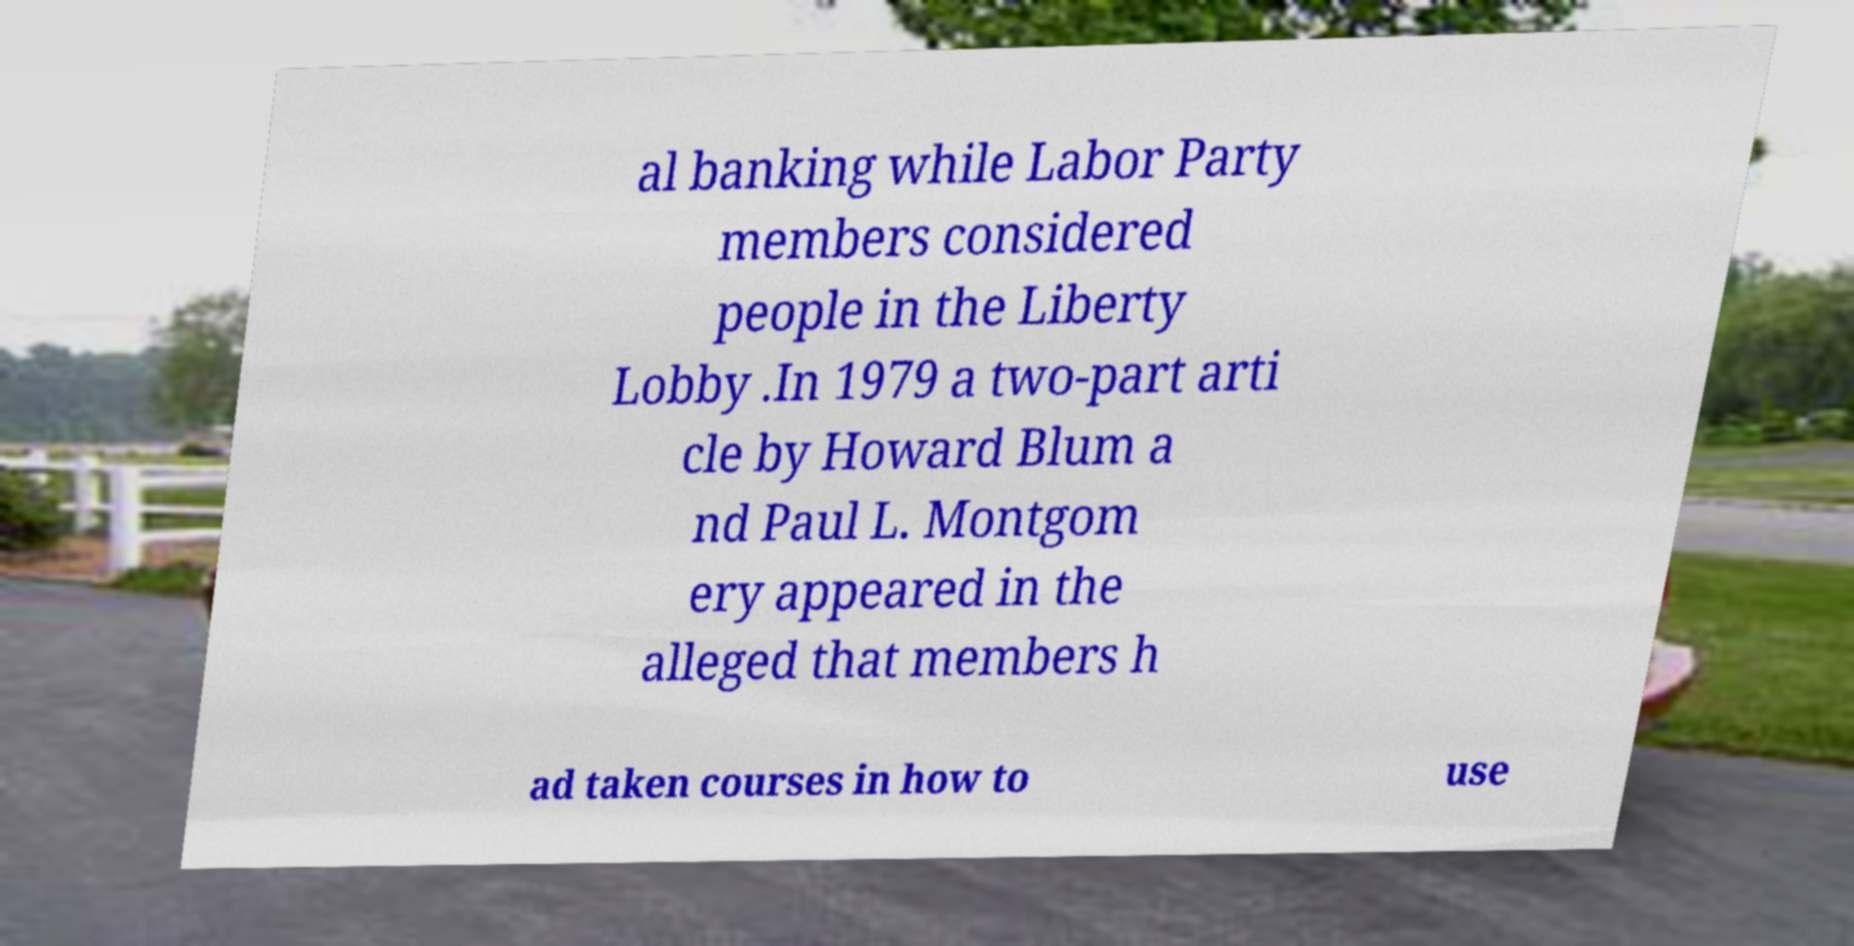Can you accurately transcribe the text from the provided image for me? al banking while Labor Party members considered people in the Liberty Lobby .In 1979 a two-part arti cle by Howard Blum a nd Paul L. Montgom ery appeared in the alleged that members h ad taken courses in how to use 